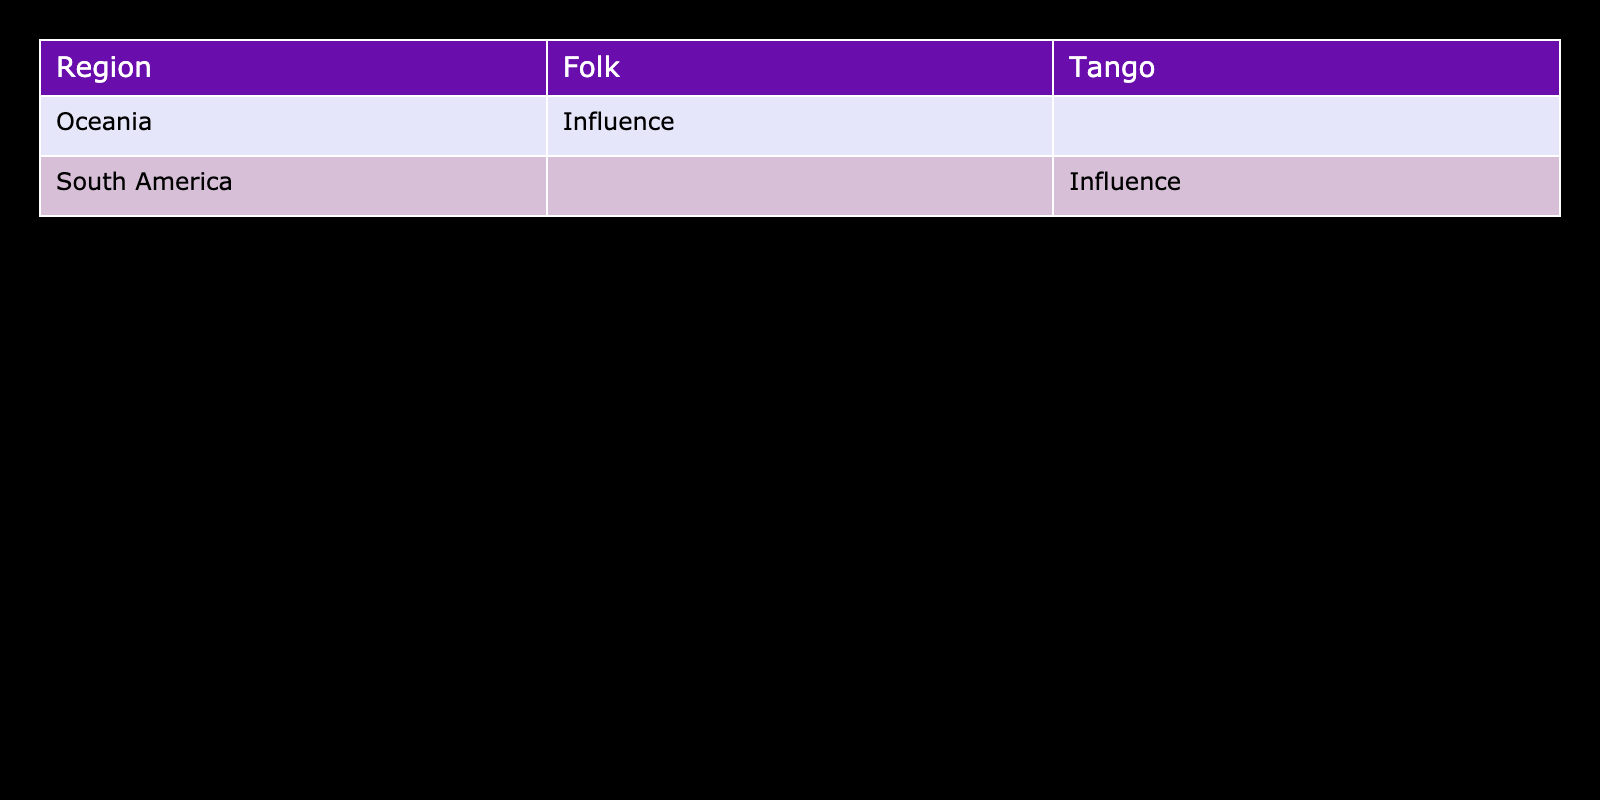What influence type is associated with Tango in South America? The table specifies that the influence type for Tango in South America is labeled as "Influence." This information can be directly found in the row pertaining to Tango under the "Influence Type" column.
Answer: Influence Which genres show influence from African-American styles in Oceania? According to the data, the genre that shows influence from African-American styles in Oceania is "Folk," specifically highlighted by "Australian Bush Music influenced by African-American styles." This can be determined by identifying the relevant row under the Oceania region.
Answer: Folk Are there any genres listed in South America that show no influence? By examining the South America entries in the table, Tango is the only genre mentioned, and it is noted as having an influence. There are no other genres listed that show no influence in this region. Thus, the answer is based on the absence of any genre without an influence status in the South America section.
Answer: No How many different genres are influenced in total across all regions presented? The table presents two distinct genres: "Tango" in South America and "Folk" in Oceania. To find the total, we count these unique genres across all listed regions, which totals to two.
Answer: 2 What is the specific example of Australian Folk influenced by African-American styles? The table lists "Australian Bush Music influenced by African-American styles" as the specific example under the Folk genre in Oceania. This can be directly found by looking in the table for the given region and genre combination.
Answer: Australian Bush Music influenced by African-American styles Is there any influence type associated with the genres listed in the table? Yes, both genres (Tango and Folk) listed in the table are associated with the influence type of "Influence." This can be confirmed by checking the influence type for each genre in their respective regions.
Answer: Yes In which region does Tango Nuevo appear, and what influence type does it represent? Tango Nuevo appears in South America, as indicated in the table. The influence type associated with it is "Influence." This involves locating Tango Nuevo in the specified region and noting down its influence type.
Answer: South America, Influence What regions show signs of African-American influence in music genres that are not Tango? The table shows that only Oceania has a genre (Folk) that describes influence from African-American styles besides Tango, which is specific to South America. To find this, we examine the regions for musical genres aside from Tango, leading us to Oceania.
Answer: Oceania 